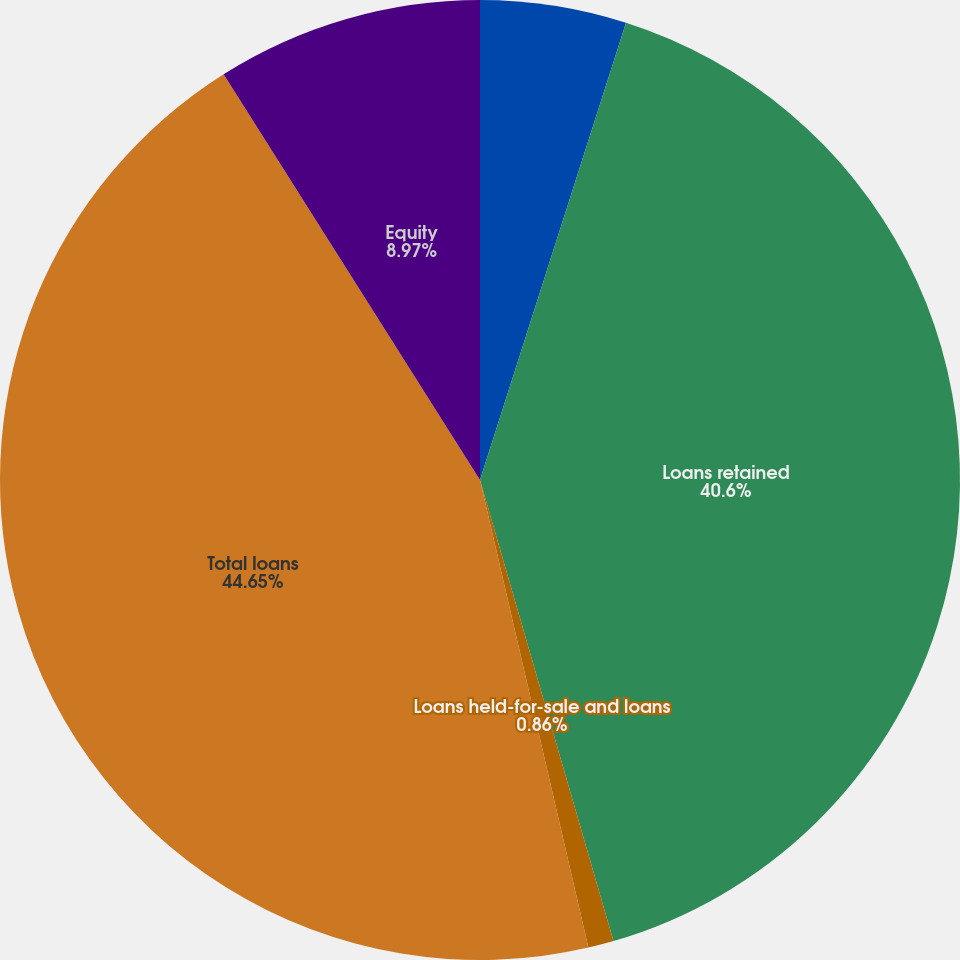Convert chart. <chart><loc_0><loc_0><loc_500><loc_500><pie_chart><fcel>Year ended December 31 (in<fcel>Loans retained<fcel>Loans held-for-sale and loans<fcel>Total loans<fcel>Equity<nl><fcel>4.92%<fcel>40.6%<fcel>0.86%<fcel>44.66%<fcel>8.97%<nl></chart> 